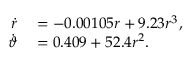<formula> <loc_0><loc_0><loc_500><loc_500>\begin{array} { r l } { \dot { r } } & = - 0 . 0 0 1 0 5 r + 9 . 2 3 r ^ { 3 } , } \\ { \dot { \vartheta } } & = 0 . 4 0 9 + 5 2 . 4 r ^ { 2 } . } \end{array}</formula> 